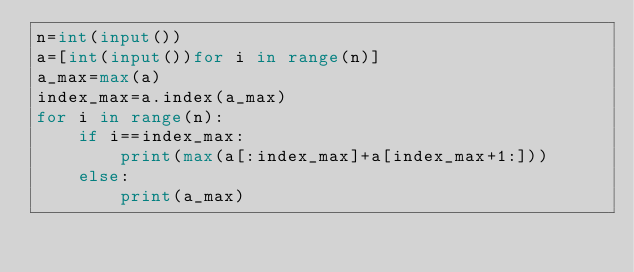Convert code to text. <code><loc_0><loc_0><loc_500><loc_500><_Python_>n=int(input())
a=[int(input())for i in range(n)]
a_max=max(a)
index_max=a.index(a_max)
for i in range(n):
    if i==index_max:
        print(max(a[:index_max]+a[index_max+1:]))
    else:
        print(a_max)</code> 